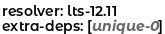<code> <loc_0><loc_0><loc_500><loc_500><_YAML_>resolver: lts-12.11
extra-deps: [unique-0]
</code> 